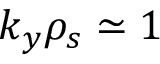<formula> <loc_0><loc_0><loc_500><loc_500>k _ { y } \rho _ { s } \simeq 1</formula> 